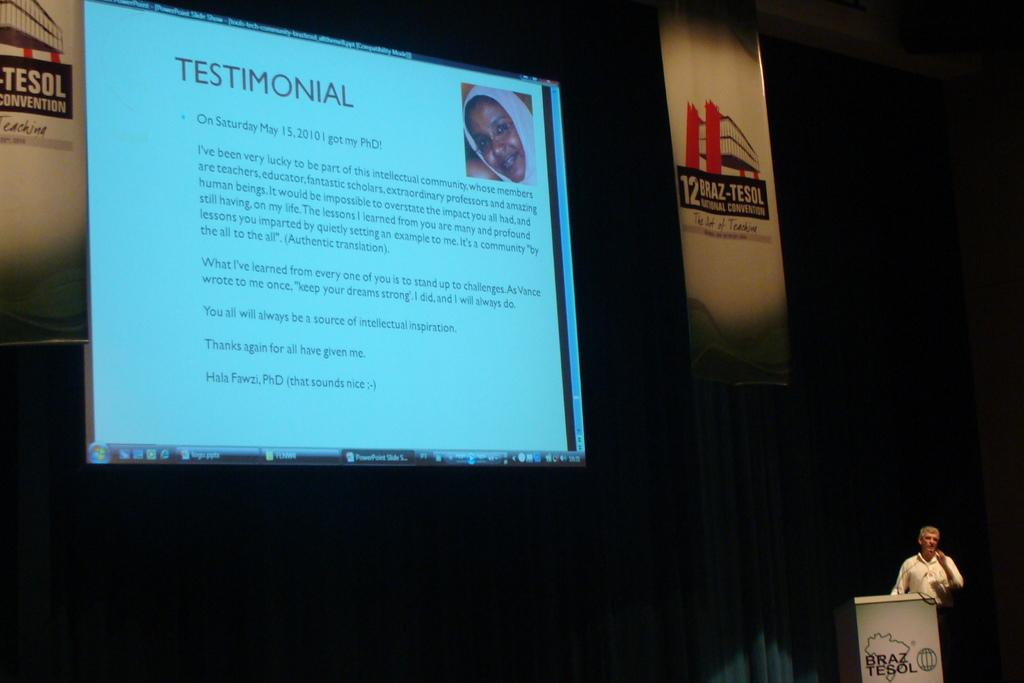What is the main object in the image? There is a screen in the image. What can be seen on the screen? Text is visible on the screen. Who is present in the image? There is a person in the image. What is the person standing near? There is a podium in the image, and the person is standing near it. What might the person be using to amplify their voice? A microphone (mic) is present in the image. What type of lip balm is the person applying in the image? There is no lip balm or any indication of the person applying anything in the image. 